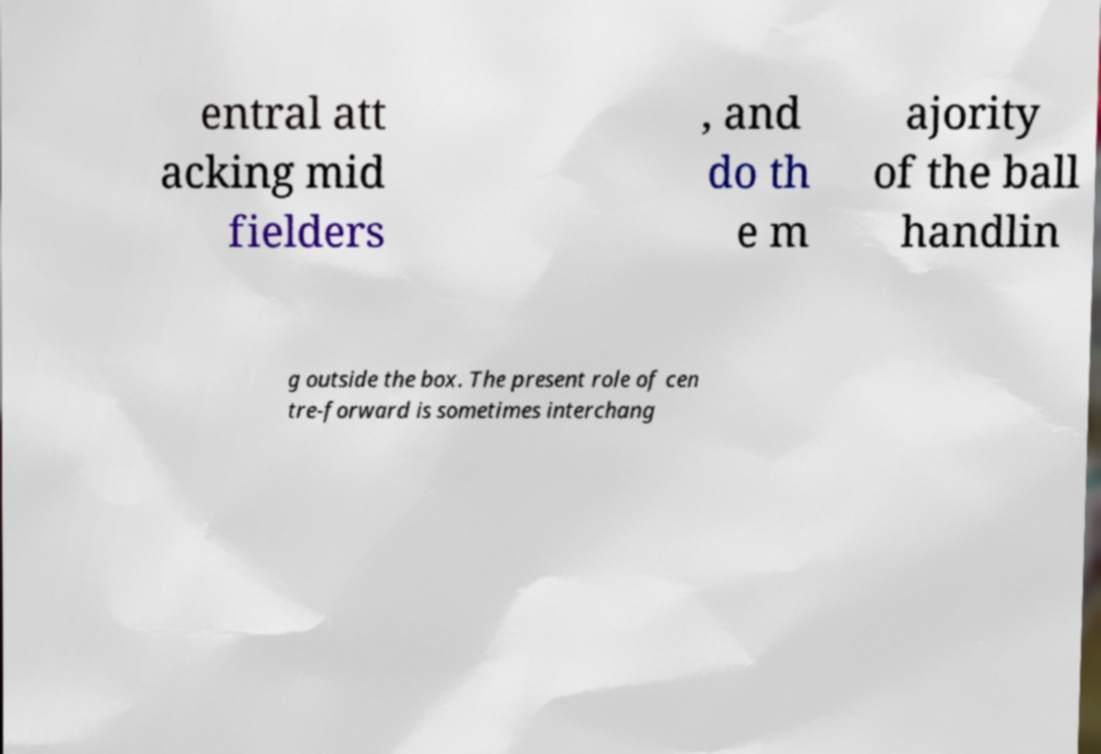Could you extract and type out the text from this image? entral att acking mid fielders , and do th e m ajority of the ball handlin g outside the box. The present role of cen tre-forward is sometimes interchang 